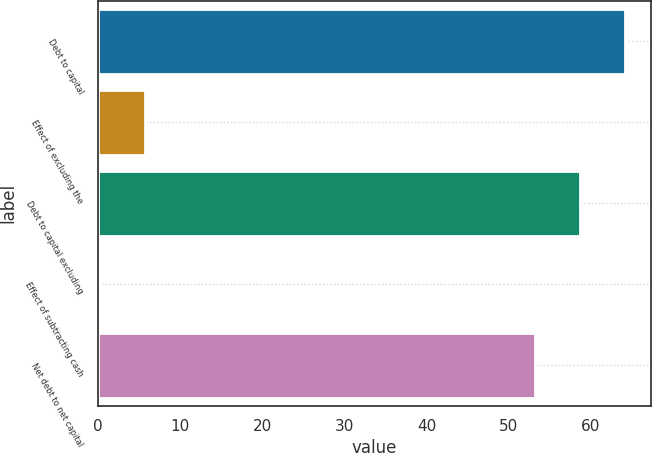Convert chart to OTSL. <chart><loc_0><loc_0><loc_500><loc_500><bar_chart><fcel>Debt to capital<fcel>Effect of excluding the<fcel>Debt to capital excluding<fcel>Effect of subtracting cash<fcel>Net debt to net capital<nl><fcel>64.14<fcel>5.77<fcel>58.67<fcel>0.3<fcel>53.2<nl></chart> 